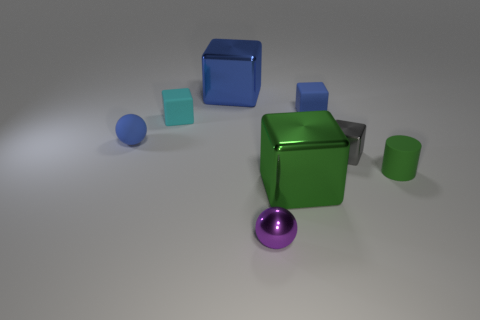The tiny purple shiny thing has what shape?
Offer a very short reply. Sphere. How many purple metallic spheres are there?
Offer a very short reply. 1. There is a metal object that is in front of the big metallic block in front of the gray object; what is its color?
Offer a very short reply. Purple. What color is the other block that is the same size as the green shiny block?
Give a very brief answer. Blue. Is there a metal cube that has the same color as the small cylinder?
Provide a succinct answer. Yes. Is there a large metal thing?
Provide a succinct answer. Yes. There is a green thing that is left of the tiny green object; what is its shape?
Provide a succinct answer. Cube. What number of blocks are in front of the large blue cube and to the left of the purple thing?
Offer a terse response. 1. How many other things are there of the same size as the cyan thing?
Offer a terse response. 5. There is a purple object to the left of the small cylinder; does it have the same shape as the large metal thing that is in front of the blue matte sphere?
Provide a short and direct response. No. 